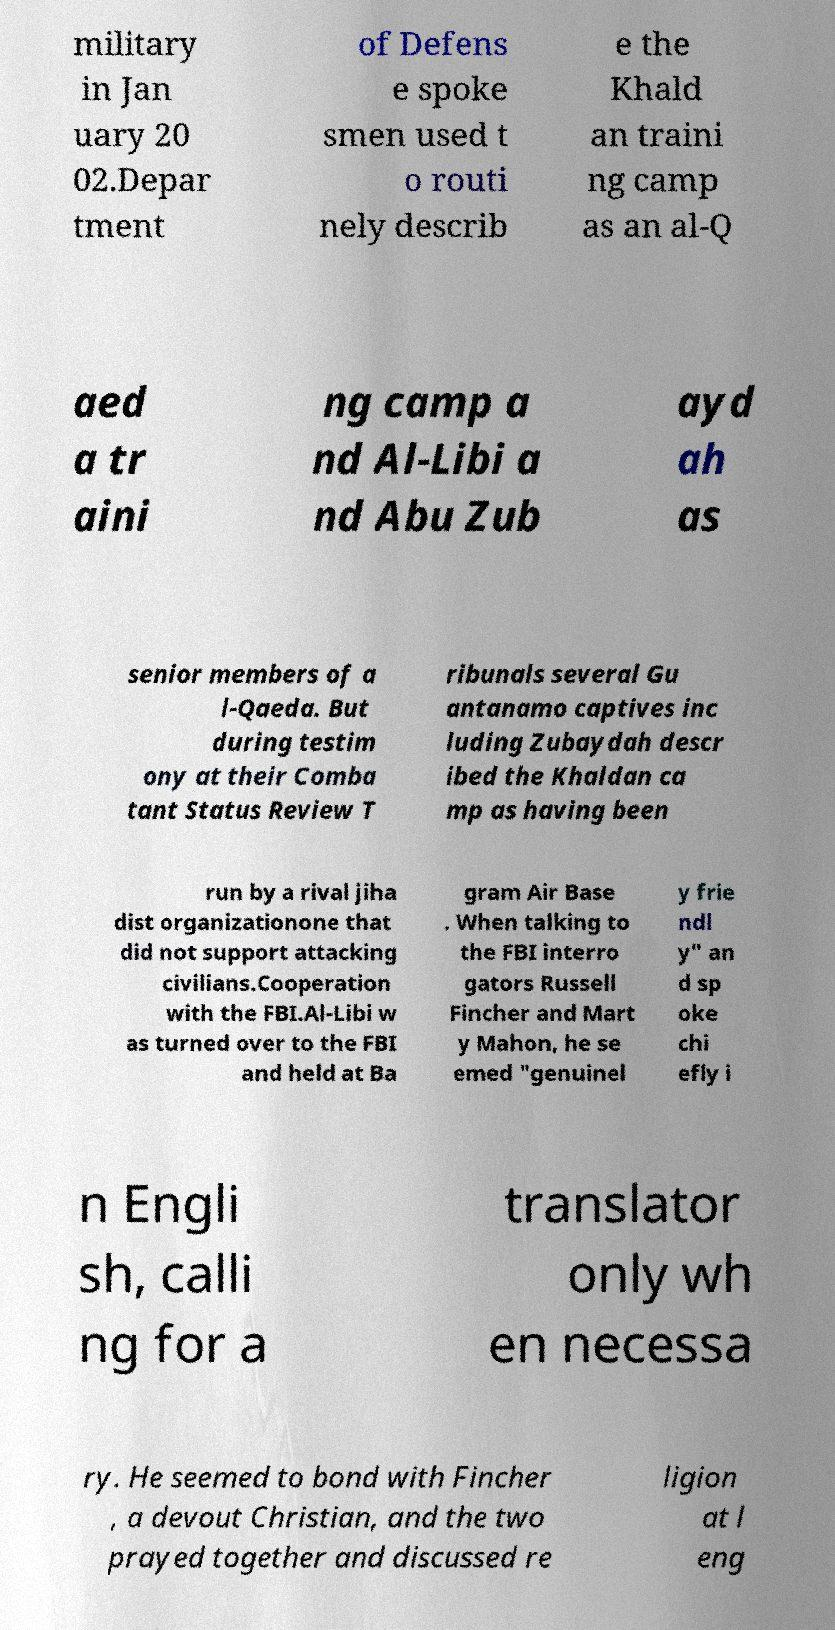What messages or text are displayed in this image? I need them in a readable, typed format. military in Jan uary 20 02.Depar tment of Defens e spoke smen used t o routi nely describ e the Khald an traini ng camp as an al-Q aed a tr aini ng camp a nd Al-Libi a nd Abu Zub ayd ah as senior members of a l-Qaeda. But during testim ony at their Comba tant Status Review T ribunals several Gu antanamo captives inc luding Zubaydah descr ibed the Khaldan ca mp as having been run by a rival jiha dist organizationone that did not support attacking civilians.Cooperation with the FBI.Al-Libi w as turned over to the FBI and held at Ba gram Air Base . When talking to the FBI interro gators Russell Fincher and Mart y Mahon, he se emed "genuinel y frie ndl y" an d sp oke chi efly i n Engli sh, calli ng for a translator only wh en necessa ry. He seemed to bond with Fincher , a devout Christian, and the two prayed together and discussed re ligion at l eng 